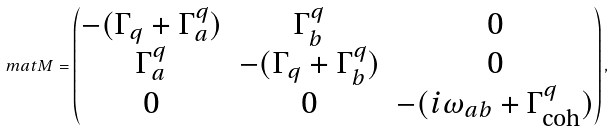<formula> <loc_0><loc_0><loc_500><loc_500>\ m a t { M } = \begin{pmatrix} - ( \Gamma _ { q } + \Gamma ^ { q } _ { a } ) & \Gamma ^ { q } _ { b } & 0 \\ \Gamma ^ { q } _ { a } & - ( \Gamma _ { q } + \Gamma ^ { q } _ { b } ) & 0 \\ 0 & 0 & - ( i \omega _ { a b } + \Gamma ^ { q } _ { \text {coh} } ) \end{pmatrix} ,</formula> 